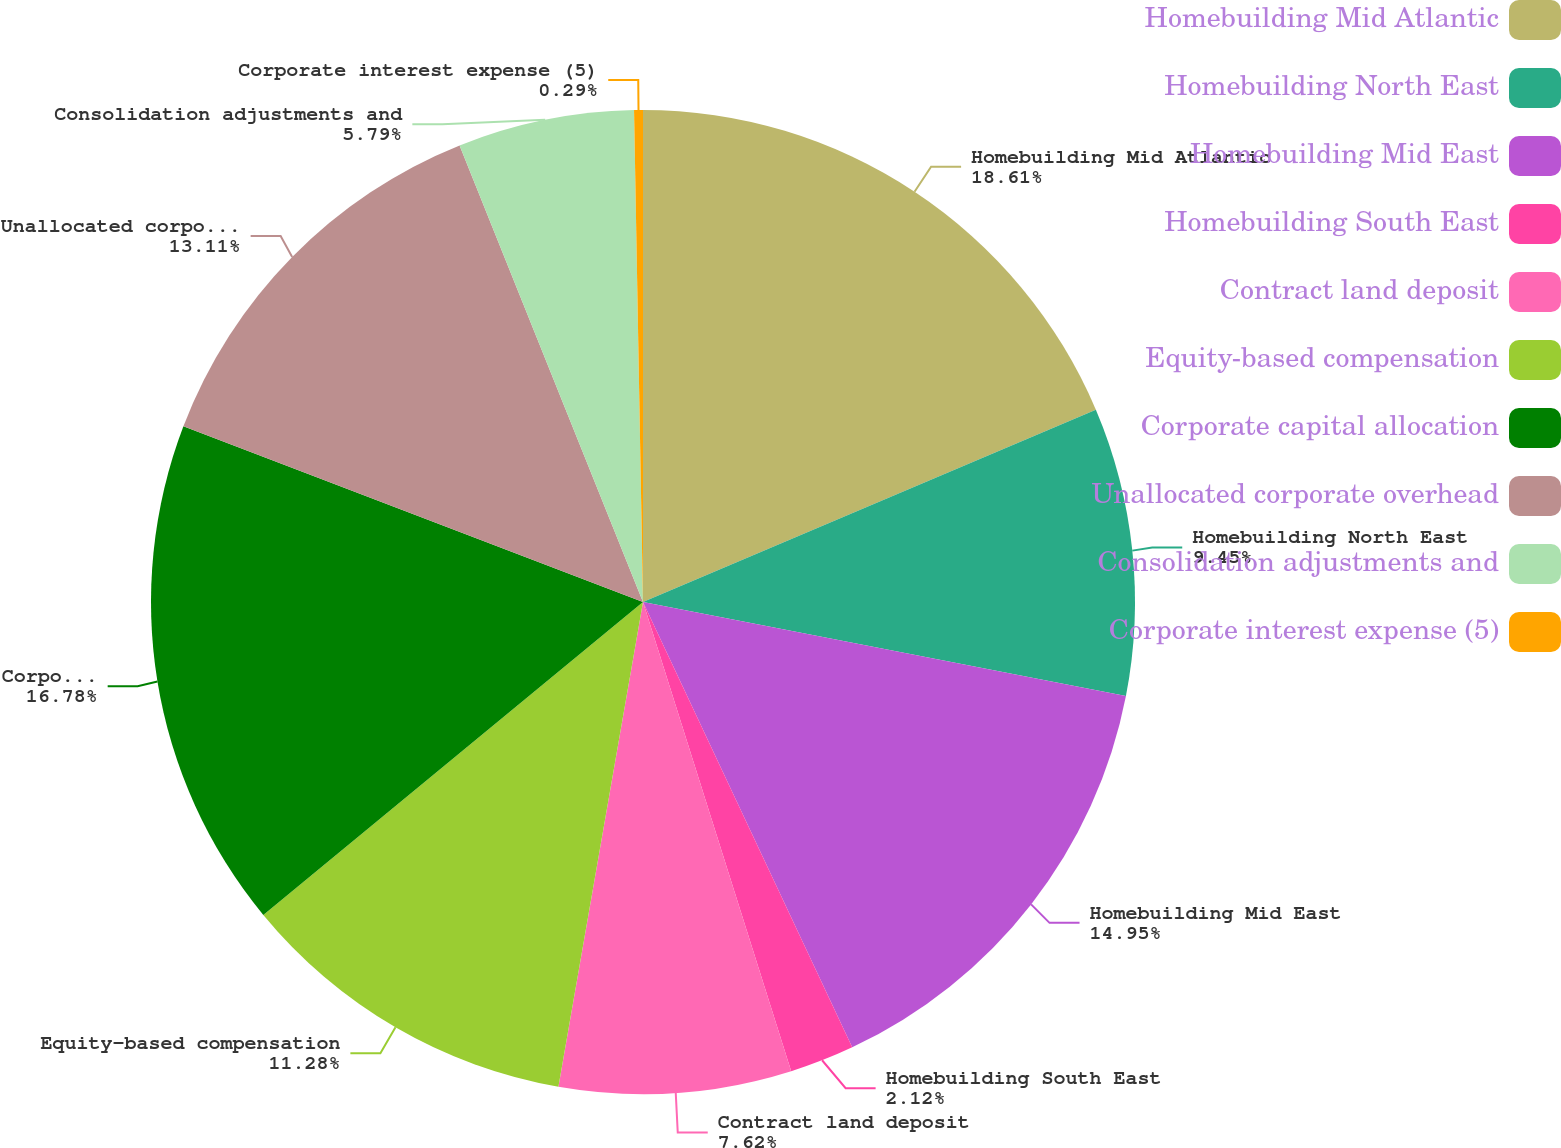Convert chart to OTSL. <chart><loc_0><loc_0><loc_500><loc_500><pie_chart><fcel>Homebuilding Mid Atlantic<fcel>Homebuilding North East<fcel>Homebuilding Mid East<fcel>Homebuilding South East<fcel>Contract land deposit<fcel>Equity-based compensation<fcel>Corporate capital allocation<fcel>Unallocated corporate overhead<fcel>Consolidation adjustments and<fcel>Corporate interest expense (5)<nl><fcel>18.61%<fcel>9.45%<fcel>14.95%<fcel>2.12%<fcel>7.62%<fcel>11.28%<fcel>16.78%<fcel>13.11%<fcel>5.79%<fcel>0.29%<nl></chart> 